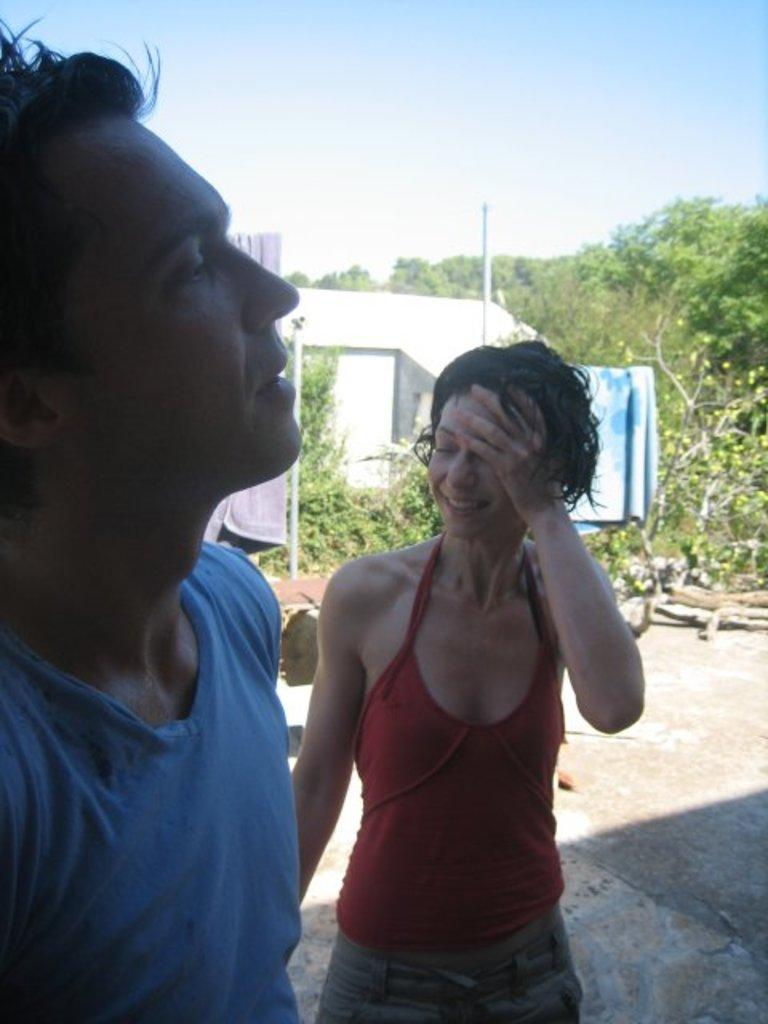How many people are in the image? There are two persons in the image. What is visible behind the persons? There are clothes visible behind the persons. What can be seen in the background of the image? There are plants, a wall, and a group of trees in the background of the image. What is visible at the top of the image? The sky is visible at the top of the image. How many cats are sitting on the calculator in the image? There are no cats or calculators present in the image. 